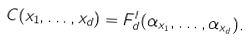<formula> <loc_0><loc_0><loc_500><loc_500>C ( x _ { 1 } , \dots , x _ { d } ) = F ^ { l } _ { d } ( \alpha _ { x _ { 1 } } , \dots , \alpha _ { x _ { d } } ) .</formula> 